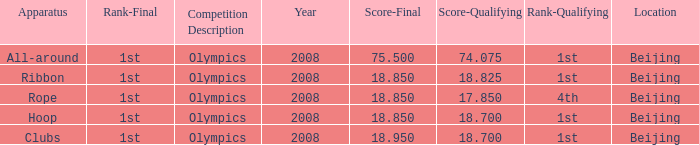On which apparatus did Kanayeva have a final score smaller than 75.5 and a qualifying score smaller than 18.7? Rope. 